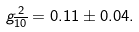<formula> <loc_0><loc_0><loc_500><loc_500>g _ { \overline { 1 0 } } ^ { \, 2 } = 0 . 1 1 \pm 0 . 0 4 .</formula> 